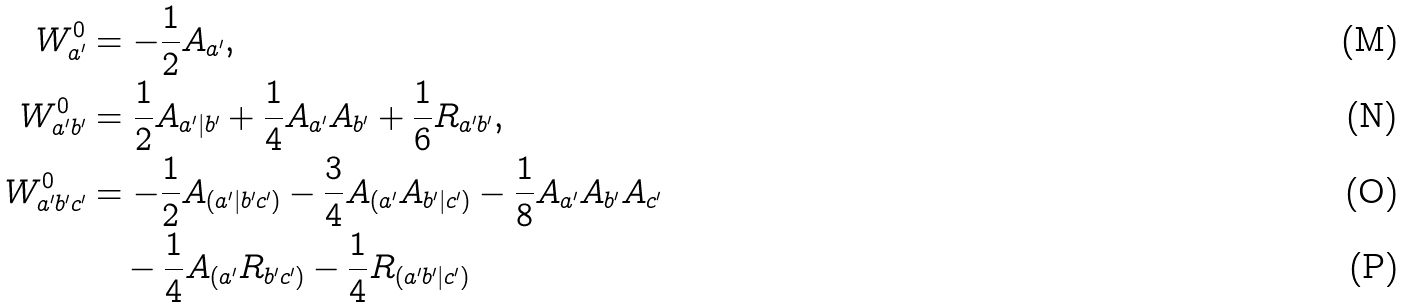<formula> <loc_0><loc_0><loc_500><loc_500>W ^ { 0 } _ { a ^ { \prime } } & = - \frac { 1 } { 2 } A _ { a ^ { \prime } } , \\ W ^ { 0 } _ { a ^ { \prime } b ^ { \prime } } & = \frac { 1 } { 2 } A _ { a ^ { \prime } | b ^ { \prime } } + \frac { 1 } { 4 } A _ { a ^ { \prime } } A _ { b ^ { \prime } } + \frac { 1 } { 6 } R _ { a ^ { \prime } b ^ { \prime } } , \\ W ^ { 0 } _ { a ^ { \prime } b ^ { \prime } c ^ { \prime } } & = - \frac { 1 } { 2 } A _ { ( a ^ { \prime } | b ^ { \prime } c ^ { \prime } ) } - \frac { 3 } { 4 } A _ { ( a ^ { \prime } } A _ { b ^ { \prime } | c ^ { \prime } ) } - \frac { 1 } { 8 } A _ { a ^ { \prime } } A _ { b ^ { \prime } } A _ { c ^ { \prime } } \\ & \quad - \frac { 1 } { 4 } A _ { ( a ^ { \prime } } R _ { b ^ { \prime } c ^ { \prime } ) } - \frac { 1 } { 4 } R _ { ( a ^ { \prime } b ^ { \prime } | c ^ { \prime } ) }</formula> 